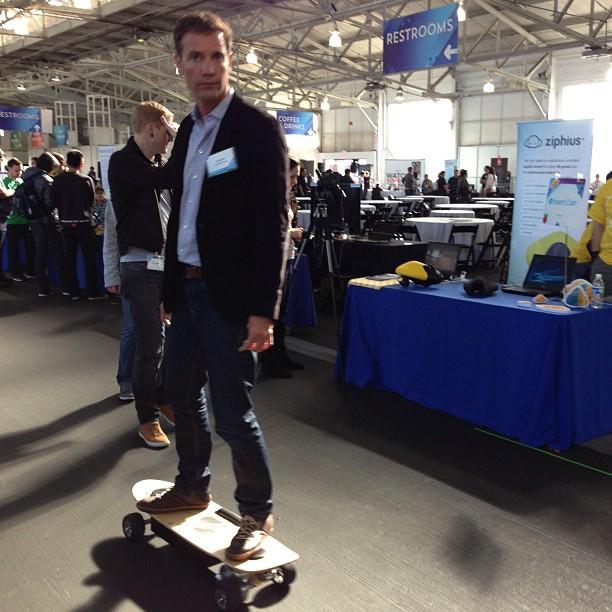Does he look like he's enjoying himself?
Short answer required. No. What is he doing?
Quick response, please. Skateboarding. Is this man a professional  skateboarder?
Concise answer only. No. 